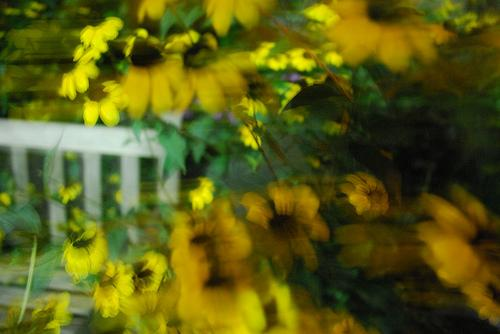In a few sentences, describe the overall sentiment or mood of this image. The image showcases a feeling of serenity and the beauty of nature. The yellow flowers are in full bloom, symbolizing joy, happiness, and optimism. List all the types of objects found in this image. yellow flowers, yellow black eyed susies, white gate, gap in gate, wood, wooden gate, petal, black center of flower, white wooden fence, wooden floor, green leaf, flower stem, reflection on glass, white railing. Identify the parts or components of the primary object in the image. Yellow petals, black center, green leaf, flower stem, and the reflection on the glass. Based on the image, what season might it be? Considering the yellow flowers are in full bloom, it might be spring or summer. What is the shape and color of the fence in this image? The fence is white and appears to be wooden with both horizontal and vertical planks. What is the main color of the flowers in the image? The main color of the flowers in the image is yellow. Connect the objects in the image in a brief narrative, using their interactions. A lively scene unfolds as yellow flowers and yellow black eyed susies bloom brightly near a white wooden fence. A green leaf reaches out from the flower stem, soaking in sunlight. One could almost feel the gentle breeze rustling the petals. What type of reasoning skill is required to figure out the main object of this image? Complex reasoning skill is required to figure out the main object of this image, as there are many different objects and interactions involved. Did you see the pink umbrella leaning against the white wooden fence? It must be there in case of rain. There is no indication of a pink umbrella or any object leaning against the white wooden fence in the given image information. The white wooden fence is present, but mentioning a pink umbrella is misleading because it doesn't exist in the image. Can you spot the red balloon floating in the sky? It's just above the horizon. There is no mention of a red balloon or any object located in the sky in the given image information. Using "red balloon" and "sky" is misleading as they are not present in the image. Observe the family of ducks swimming in a pond beside the yellow flowers. Can you count how many there are? There is no mention of ducks, a pond, or any water feature in the given image information. Introducing a family of ducks and asking to count them is misleading since they do not exist in the image. Do you notice the little girl wearing a green dress standing near the small white gate? She seems to be enjoying the flowers. There is no mention of a little girl or any human figure in the provided image information. Making up a character like a little girl in a green dress and placing her near the small white gate is misleading as she is not part of the image. Look at the tiny purple butterfly resting on a yellow flower. Isn't it so delicate and beautiful? Although there are yellow flowers in the image, there is no mention of a butterfly, especially a purple one, resting on any of them. Therefore, the instruction is misleading as it introduces a non-existent object (purple butterfly) to the scene. Notice how the blue cat is sitting comfortably on the wooden floor. What a lovely scene! There is no mention of a cat, especially a blue cat, in the provided image information. The wooden floor is present in the image, but associating it with a blue cat is misleading as there is no cat present. 